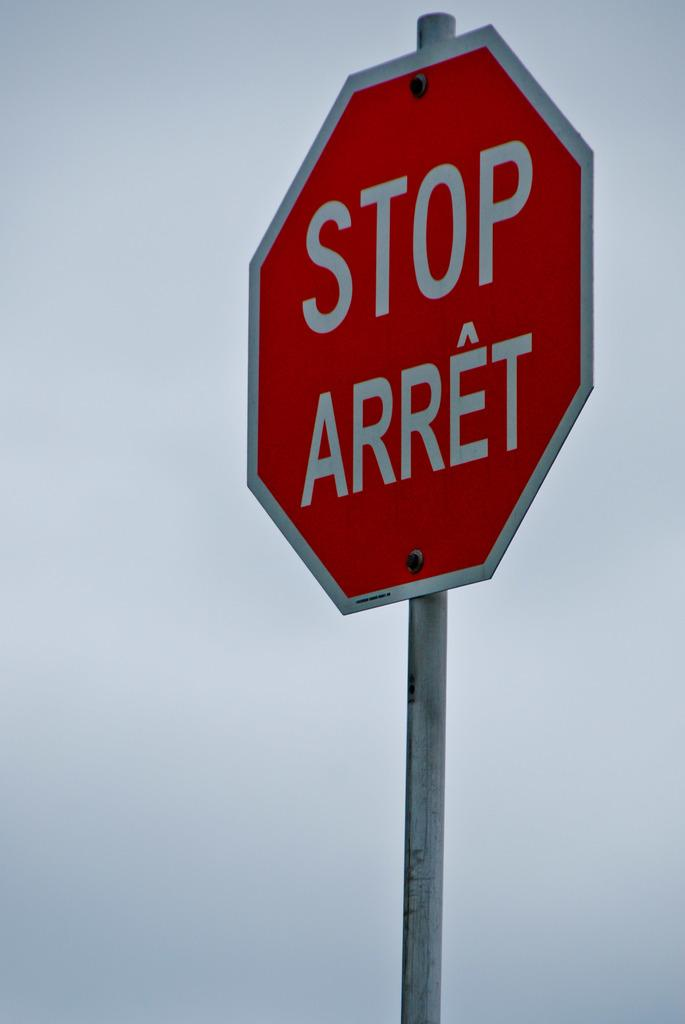Provide a one-sentence caption for the provided image. A sign that says STOP ARRET on it. 